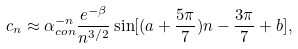Convert formula to latex. <formula><loc_0><loc_0><loc_500><loc_500>c _ { n } \approx \alpha _ { c o n } ^ { - n } \frac { e ^ { - \beta } } { n ^ { 3 / 2 } } \sin [ ( a + \frac { 5 \pi } { 7 } ) n - \frac { 3 \pi } { 7 } + b ] ,</formula> 